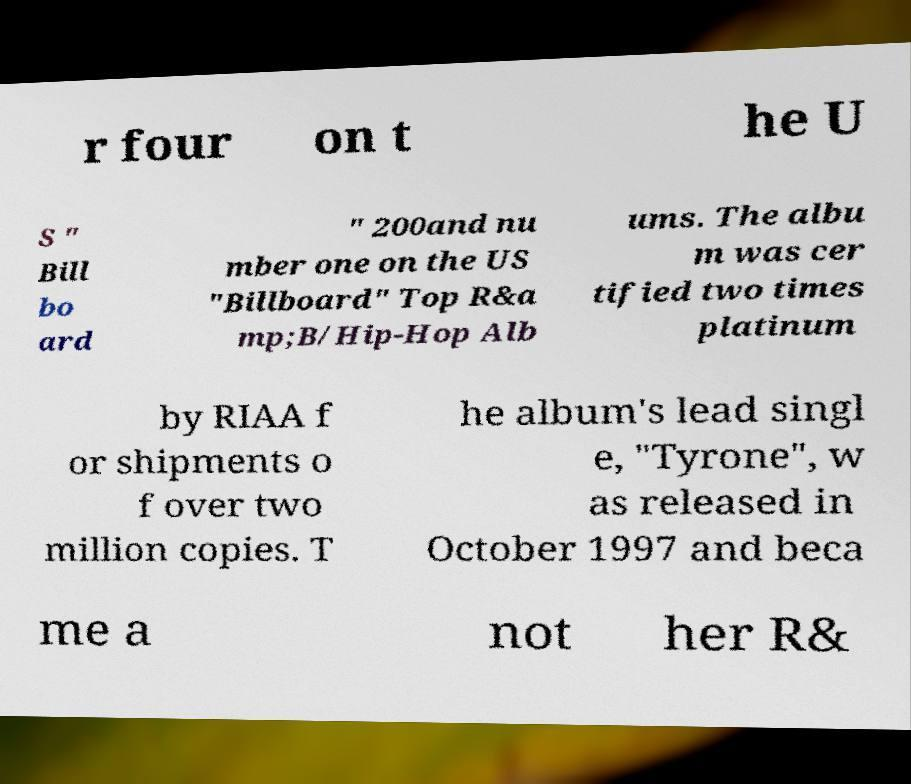Can you read and provide the text displayed in the image?This photo seems to have some interesting text. Can you extract and type it out for me? r four on t he U S " Bill bo ard " 200and nu mber one on the US "Billboard" Top R&a mp;B/Hip-Hop Alb ums. The albu m was cer tified two times platinum by RIAA f or shipments o f over two million copies. T he album's lead singl e, "Tyrone", w as released in October 1997 and beca me a not her R& 